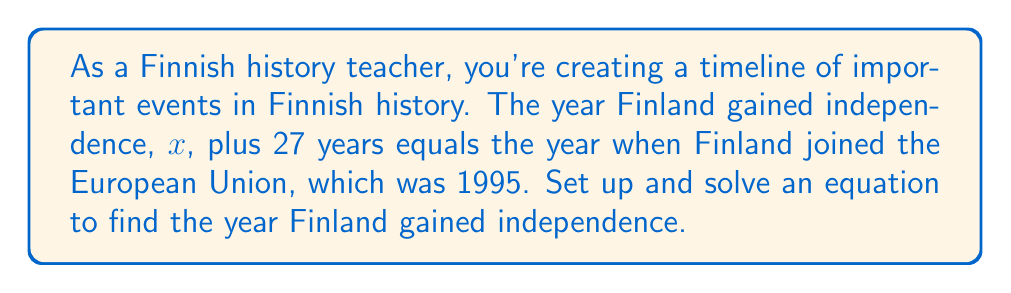Give your solution to this math problem. Let's approach this step-by-step:

1) First, let's set up our equation based on the given information:
   
   $x + 27 = 1995$

   Where $x$ represents the year Finland gained independence.

2) To solve for $x$, we need to isolate it on one side of the equation. We can do this by subtracting 27 from both sides:

   $x + 27 - 27 = 1995 - 27$

3) Simplifying:

   $x = 1968$

4) Let's verify our answer:
   
   $1968 + 27 = 1995$

   This checks out, confirming our solution.

Therefore, according to our equation, Finland gained independence in 1968. However, as a history teacher, you should note that the actual year of Finnish independence was 1917. This problem demonstrates how mathematical models can be used to explore historical timelines, even if the specific years used in this example are not historically accurate.
Answer: $x = 1968$ 